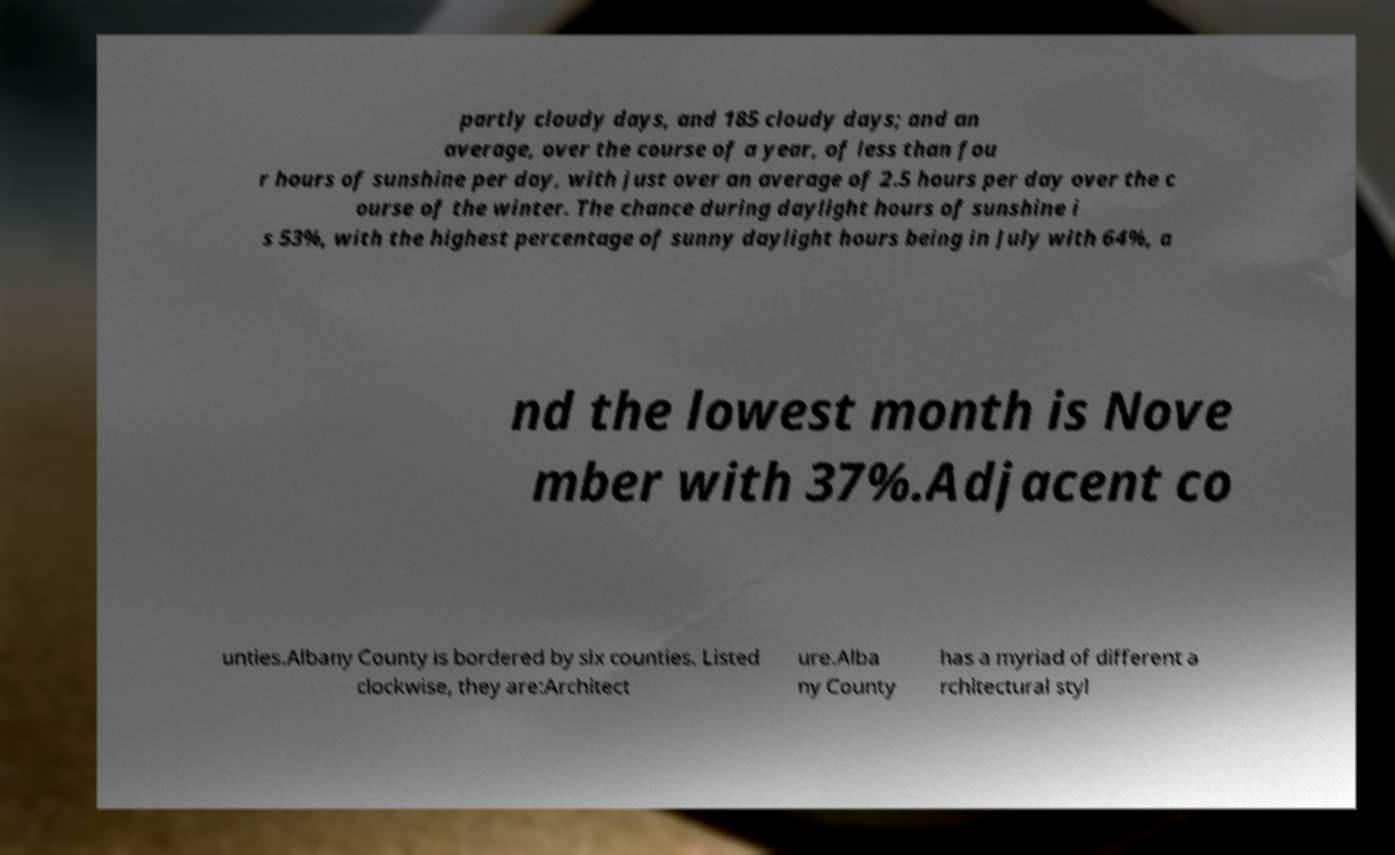Please identify and transcribe the text found in this image. partly cloudy days, and 185 cloudy days; and an average, over the course of a year, of less than fou r hours of sunshine per day, with just over an average of 2.5 hours per day over the c ourse of the winter. The chance during daylight hours of sunshine i s 53%, with the highest percentage of sunny daylight hours being in July with 64%, a nd the lowest month is Nove mber with 37%.Adjacent co unties.Albany County is bordered by six counties. Listed clockwise, they are:Architect ure.Alba ny County has a myriad of different a rchitectural styl 